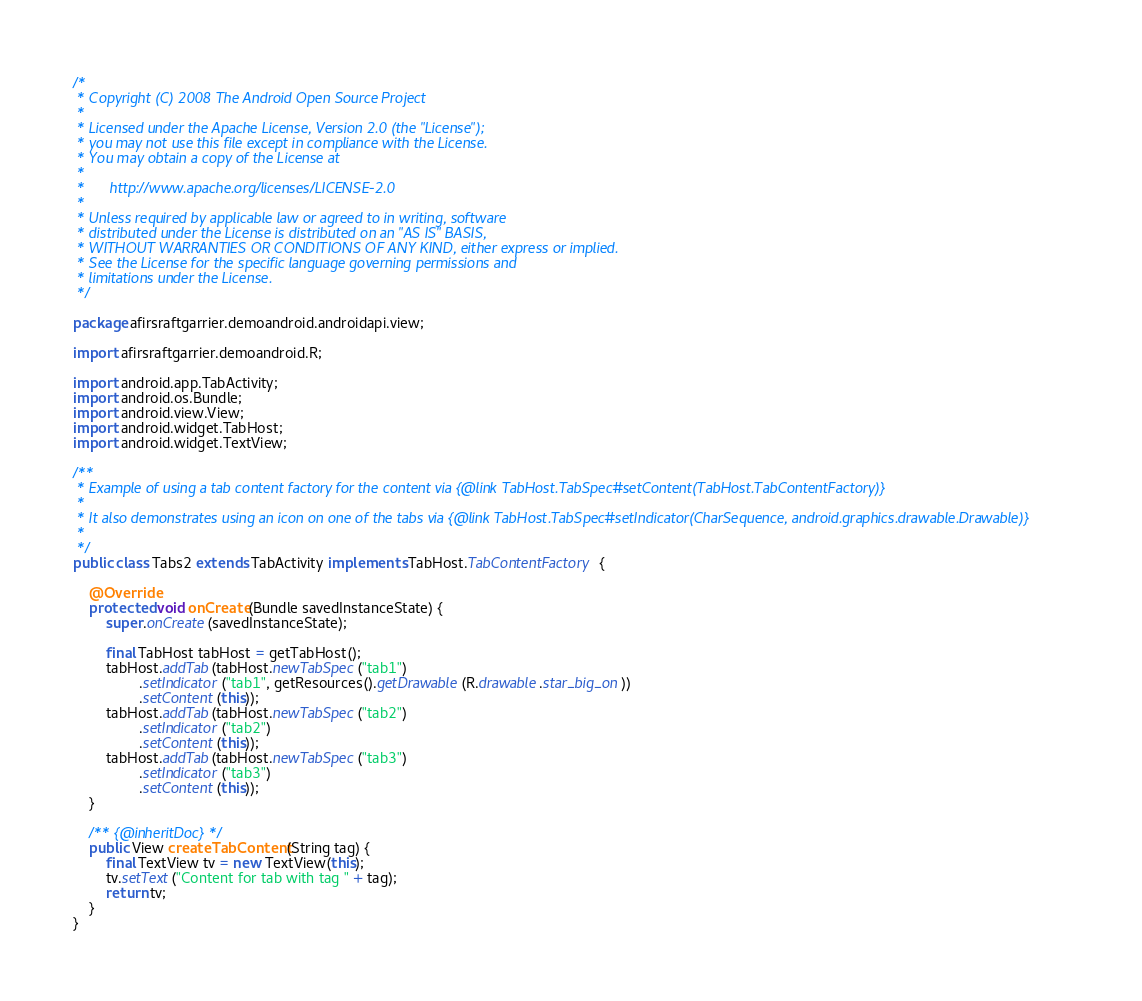<code> <loc_0><loc_0><loc_500><loc_500><_Java_>/*
 * Copyright (C) 2008 The Android Open Source Project
 *
 * Licensed under the Apache License, Version 2.0 (the "License");
 * you may not use this file except in compliance with the License.
 * You may obtain a copy of the License at
 *
 *      http://www.apache.org/licenses/LICENSE-2.0
 *
 * Unless required by applicable law or agreed to in writing, software
 * distributed under the License is distributed on an "AS IS" BASIS,
 * WITHOUT WARRANTIES OR CONDITIONS OF ANY KIND, either express or implied.
 * See the License for the specific language governing permissions and
 * limitations under the License.
 */

package afirsraftgarrier.demoandroid.androidapi.view;

import afirsraftgarrier.demoandroid.R;

import android.app.TabActivity;
import android.os.Bundle;
import android.view.View;
import android.widget.TabHost;
import android.widget.TextView;

/**
 * Example of using a tab content factory for the content via {@link TabHost.TabSpec#setContent(TabHost.TabContentFactory)}
 *
 * It also demonstrates using an icon on one of the tabs via {@link TabHost.TabSpec#setIndicator(CharSequence, android.graphics.drawable.Drawable)}
 *
 */
public class Tabs2 extends TabActivity implements TabHost.TabContentFactory {

    @Override
    protected void onCreate(Bundle savedInstanceState) {
        super.onCreate(savedInstanceState);

        final TabHost tabHost = getTabHost();
        tabHost.addTab(tabHost.newTabSpec("tab1")
                .setIndicator("tab1", getResources().getDrawable(R.drawable.star_big_on))
                .setContent(this));
        tabHost.addTab(tabHost.newTabSpec("tab2")
                .setIndicator("tab2")
                .setContent(this));
        tabHost.addTab(tabHost.newTabSpec("tab3")
                .setIndicator("tab3")
                .setContent(this));
    }

    /** {@inheritDoc} */
    public View createTabContent(String tag) {
        final TextView tv = new TextView(this);
        tv.setText("Content for tab with tag " + tag);
        return tv;
    }
}
</code> 